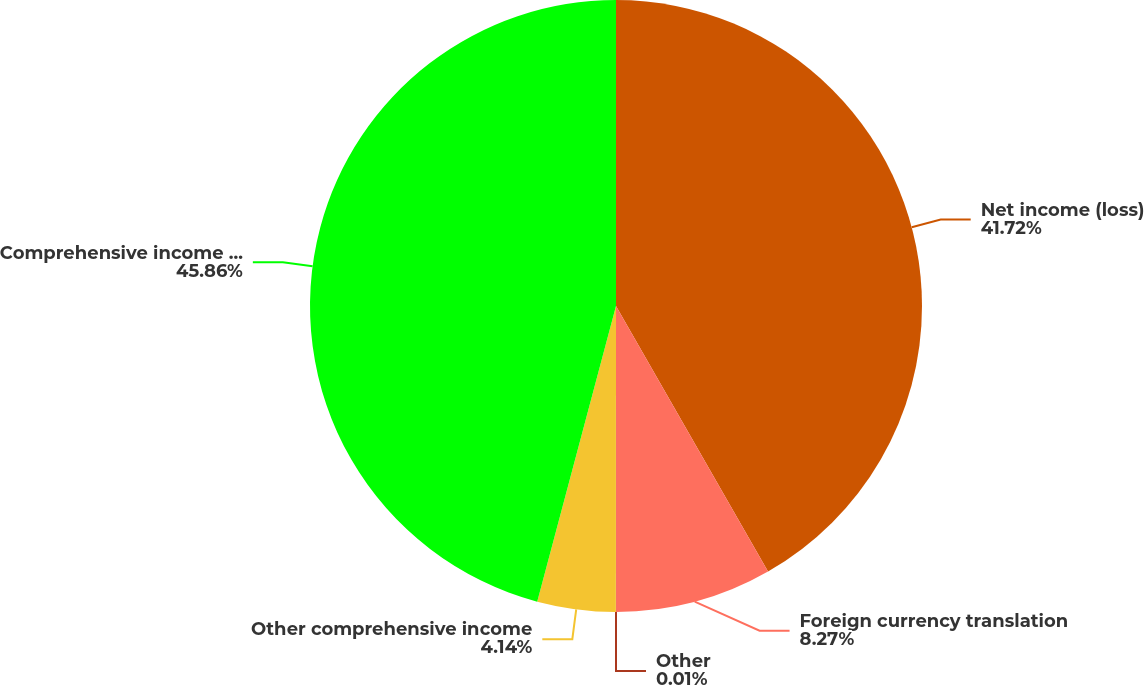Convert chart. <chart><loc_0><loc_0><loc_500><loc_500><pie_chart><fcel>Net income (loss)<fcel>Foreign currency translation<fcel>Other<fcel>Other comprehensive income<fcel>Comprehensive income (loss)<nl><fcel>41.72%<fcel>8.27%<fcel>0.01%<fcel>4.14%<fcel>45.85%<nl></chart> 